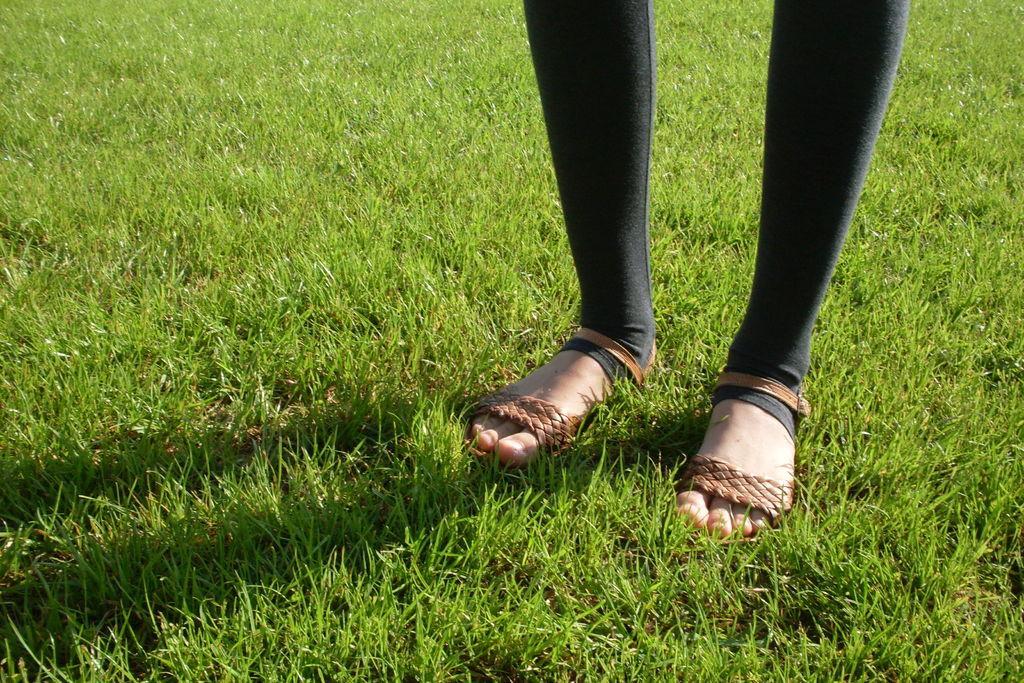In one or two sentences, can you explain what this image depicts? In this image we can see a person's leg and we can see the grass on the ground. 